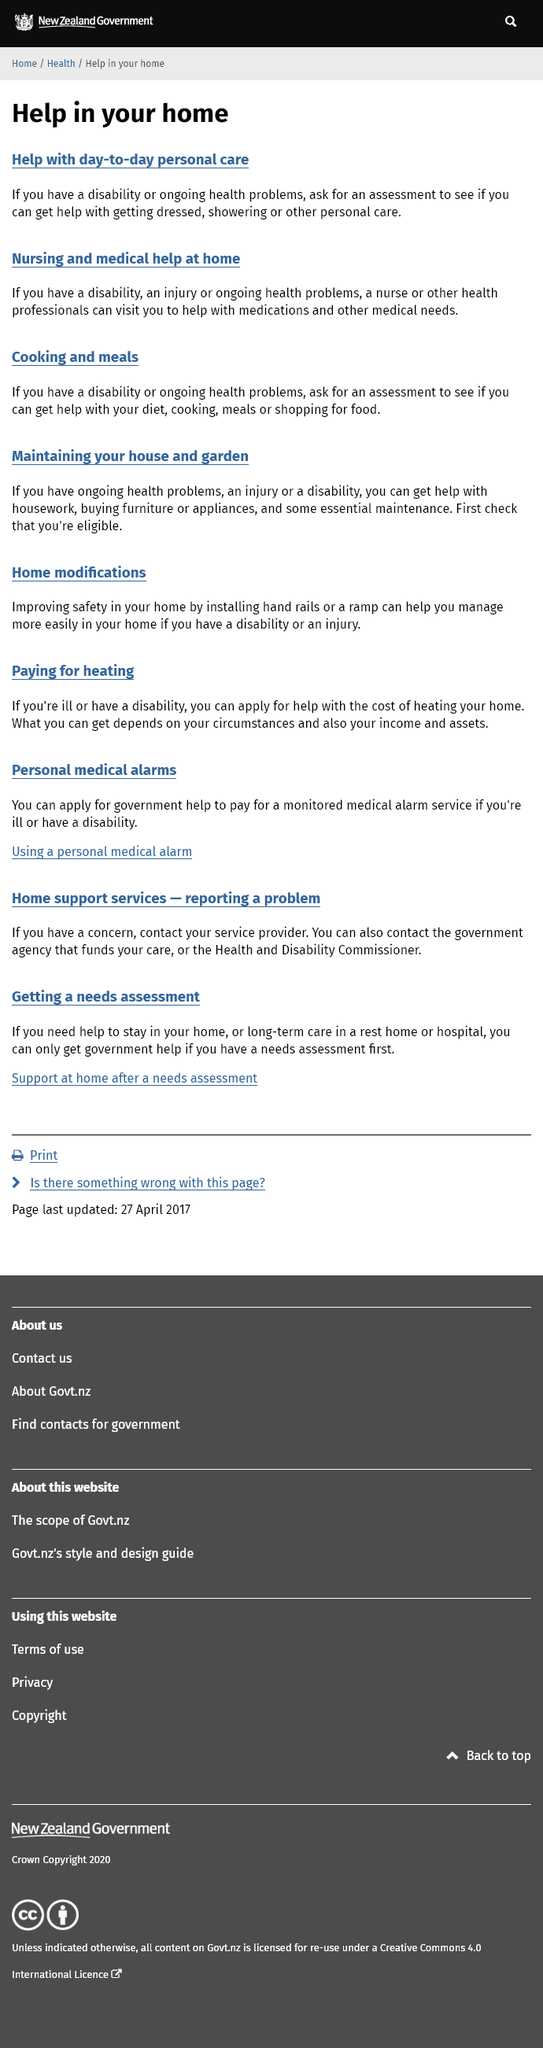Indicate a few pertinent items in this graphic. Disabled individuals are entitled to receive assistance with shopping, housework, and personal care. It is known that health professionals are capable of providing assistance with medications and other medical necessities, as evidenced by their extensive training and experience in the field. Yes, injured people can receive assistance with housework. 